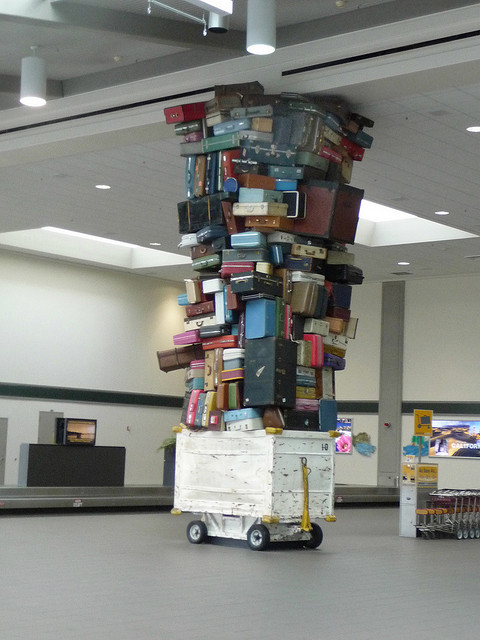How many pieces of luggage can you count? It's not possible to count every piece of luggage precisely due to the angle and distance, but a rough estimate would be around fifty to seventy pieces, considering the visible sides and assuming a similar number out of view. 